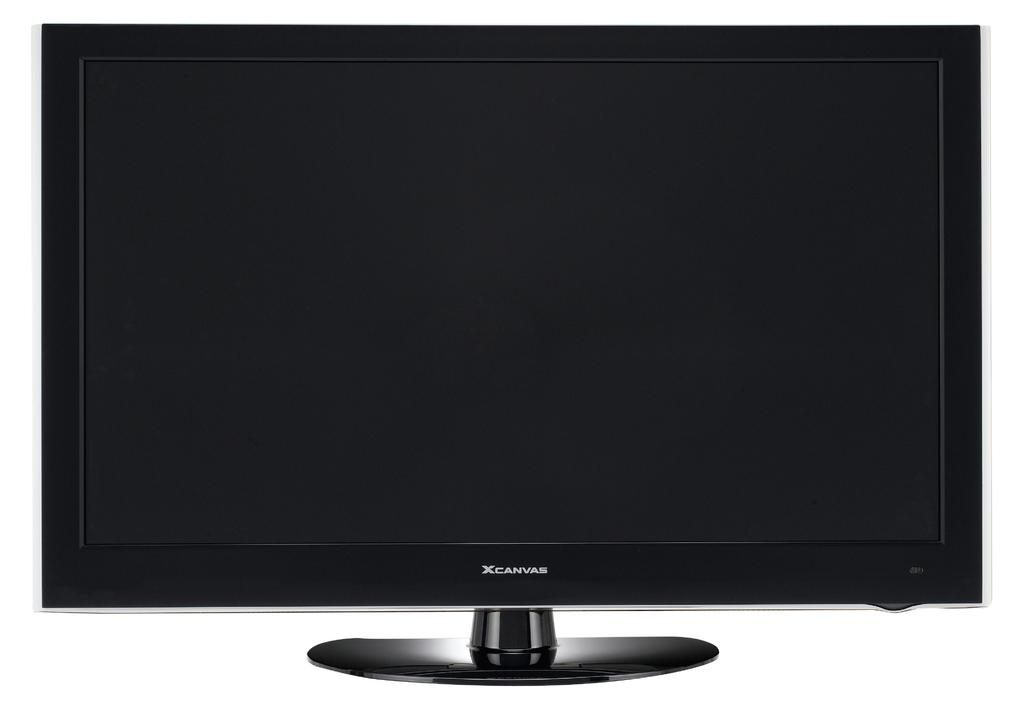<image>
Offer a succinct explanation of the picture presented. A Xcanvas monitor is currently powered off and blank. 